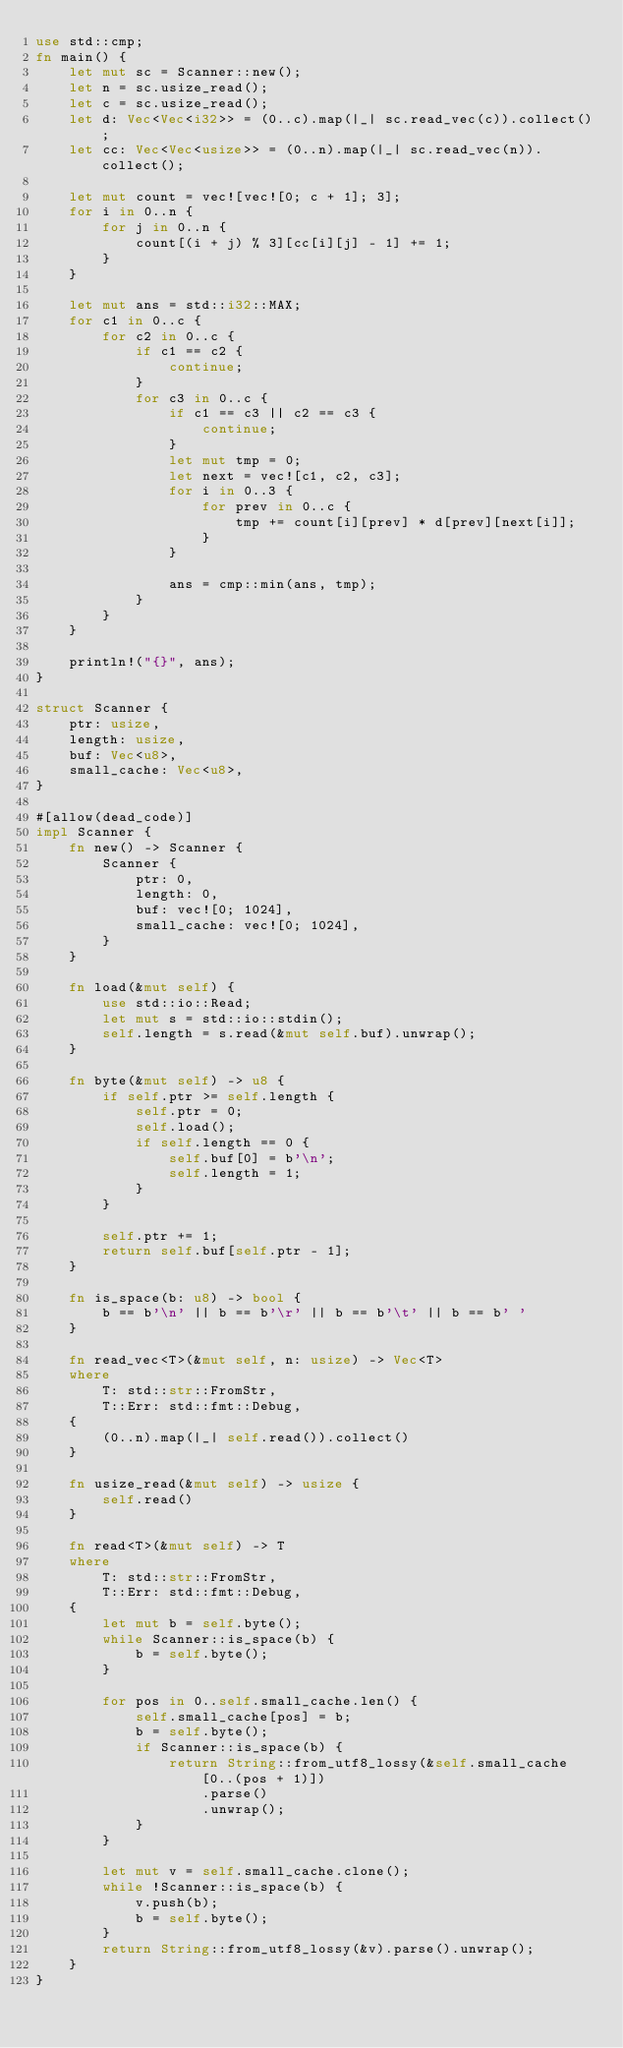<code> <loc_0><loc_0><loc_500><loc_500><_Rust_>use std::cmp;
fn main() {
    let mut sc = Scanner::new();
    let n = sc.usize_read();
    let c = sc.usize_read();
    let d: Vec<Vec<i32>> = (0..c).map(|_| sc.read_vec(c)).collect();
    let cc: Vec<Vec<usize>> = (0..n).map(|_| sc.read_vec(n)).collect();

    let mut count = vec![vec![0; c + 1]; 3];
    for i in 0..n {
        for j in 0..n {
            count[(i + j) % 3][cc[i][j] - 1] += 1;
        }
    }

    let mut ans = std::i32::MAX;
    for c1 in 0..c {
        for c2 in 0..c {
            if c1 == c2 {
                continue;
            }
            for c3 in 0..c {
                if c1 == c3 || c2 == c3 {
                    continue;
                }
                let mut tmp = 0;
                let next = vec![c1, c2, c3];
                for i in 0..3 {
                    for prev in 0..c {
                        tmp += count[i][prev] * d[prev][next[i]];
                    }
                }

                ans = cmp::min(ans, tmp);
            }
        }
    }

    println!("{}", ans);
}

struct Scanner {
    ptr: usize,
    length: usize,
    buf: Vec<u8>,
    small_cache: Vec<u8>,
}

#[allow(dead_code)]
impl Scanner {
    fn new() -> Scanner {
        Scanner {
            ptr: 0,
            length: 0,
            buf: vec![0; 1024],
            small_cache: vec![0; 1024],
        }
    }

    fn load(&mut self) {
        use std::io::Read;
        let mut s = std::io::stdin();
        self.length = s.read(&mut self.buf).unwrap();
    }

    fn byte(&mut self) -> u8 {
        if self.ptr >= self.length {
            self.ptr = 0;
            self.load();
            if self.length == 0 {
                self.buf[0] = b'\n';
                self.length = 1;
            }
        }

        self.ptr += 1;
        return self.buf[self.ptr - 1];
    }

    fn is_space(b: u8) -> bool {
        b == b'\n' || b == b'\r' || b == b'\t' || b == b' '
    }

    fn read_vec<T>(&mut self, n: usize) -> Vec<T>
    where
        T: std::str::FromStr,
        T::Err: std::fmt::Debug,
    {
        (0..n).map(|_| self.read()).collect()
    }

    fn usize_read(&mut self) -> usize {
        self.read()
    }

    fn read<T>(&mut self) -> T
    where
        T: std::str::FromStr,
        T::Err: std::fmt::Debug,
    {
        let mut b = self.byte();
        while Scanner::is_space(b) {
            b = self.byte();
        }

        for pos in 0..self.small_cache.len() {
            self.small_cache[pos] = b;
            b = self.byte();
            if Scanner::is_space(b) {
                return String::from_utf8_lossy(&self.small_cache[0..(pos + 1)])
                    .parse()
                    .unwrap();
            }
        }

        let mut v = self.small_cache.clone();
        while !Scanner::is_space(b) {
            v.push(b);
            b = self.byte();
        }
        return String::from_utf8_lossy(&v).parse().unwrap();
    }
}
</code> 